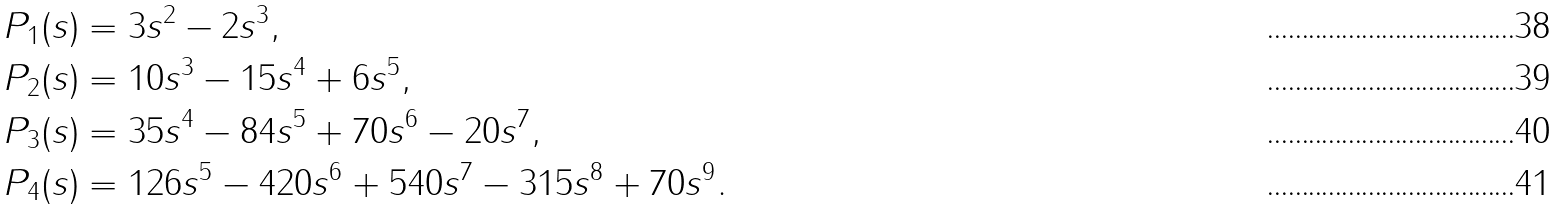<formula> <loc_0><loc_0><loc_500><loc_500>P _ { 1 } ( s ) & = 3 s ^ { 2 } - 2 s ^ { 3 } , \\ P _ { 2 } ( s ) & = 1 0 s ^ { 3 } - 1 5 s ^ { 4 } + 6 s ^ { 5 } , \\ P _ { 3 } ( s ) & = 3 5 s ^ { 4 } - 8 4 s ^ { 5 } + 7 0 s ^ { 6 } - 2 0 s ^ { 7 } , \\ P _ { 4 } ( s ) & = 1 2 6 s ^ { 5 } - 4 2 0 s ^ { 6 } + 5 4 0 s ^ { 7 } - 3 1 5 s ^ { 8 } + 7 0 s ^ { 9 } .</formula> 